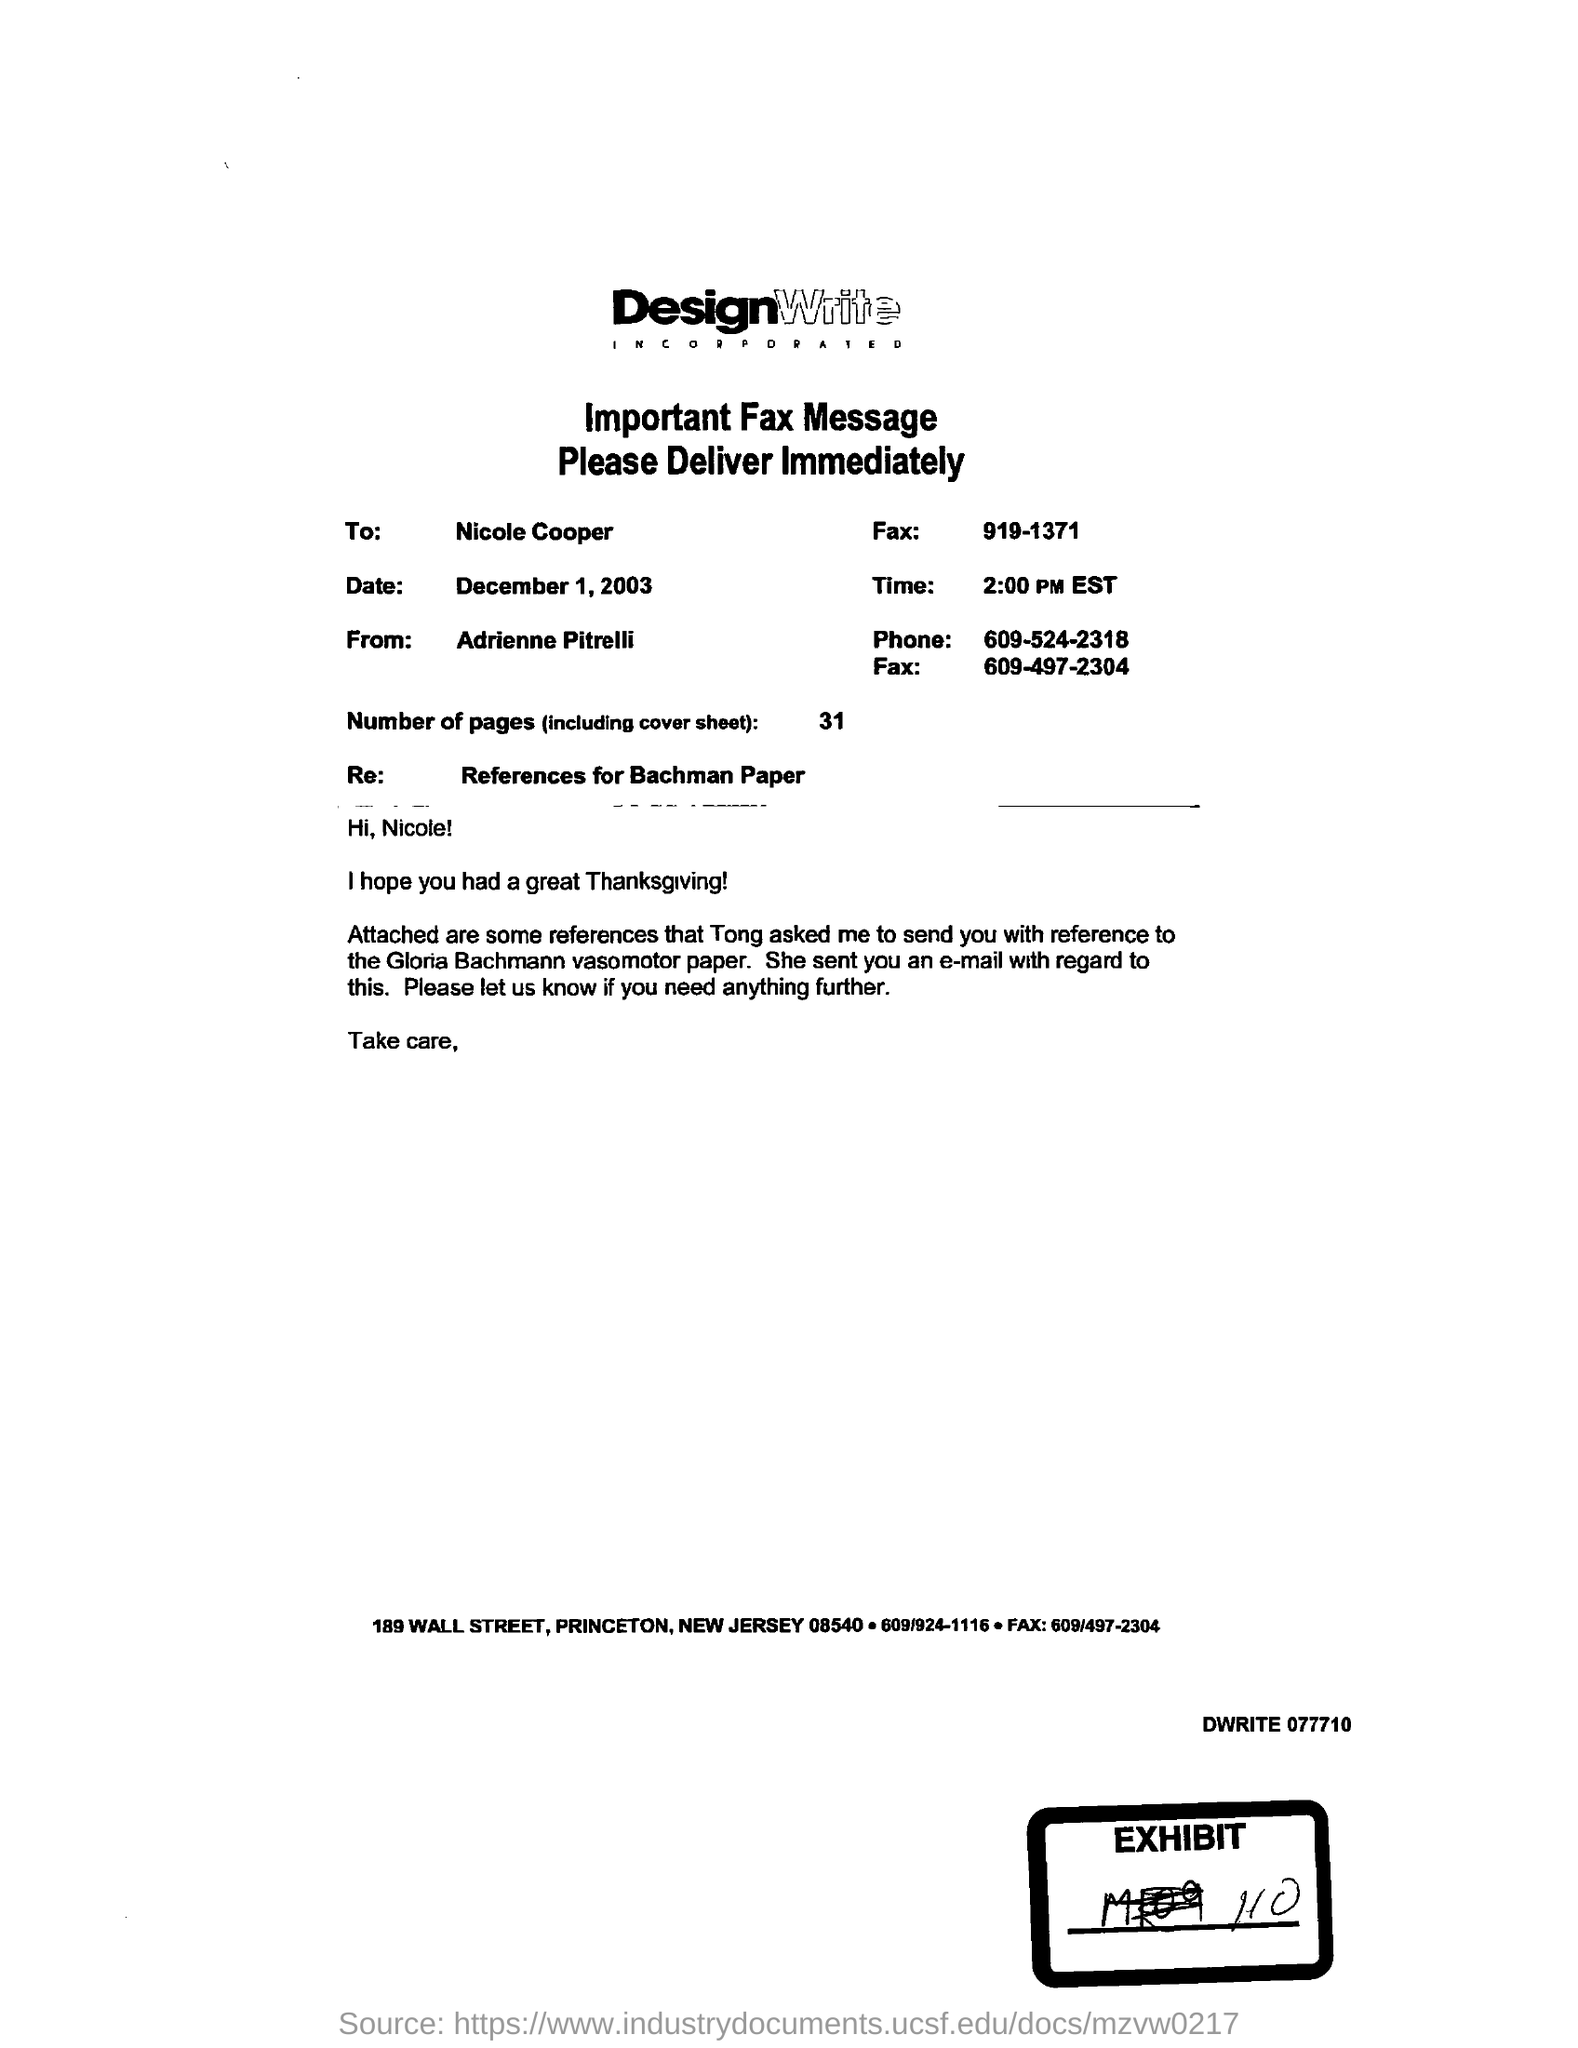List a handful of essential elements in this visual. The date is December 1, 2003. It is currently 2:00 PM in Eastern Standard Time. The number of pages is 31. The phone number is 609-524-2318. 